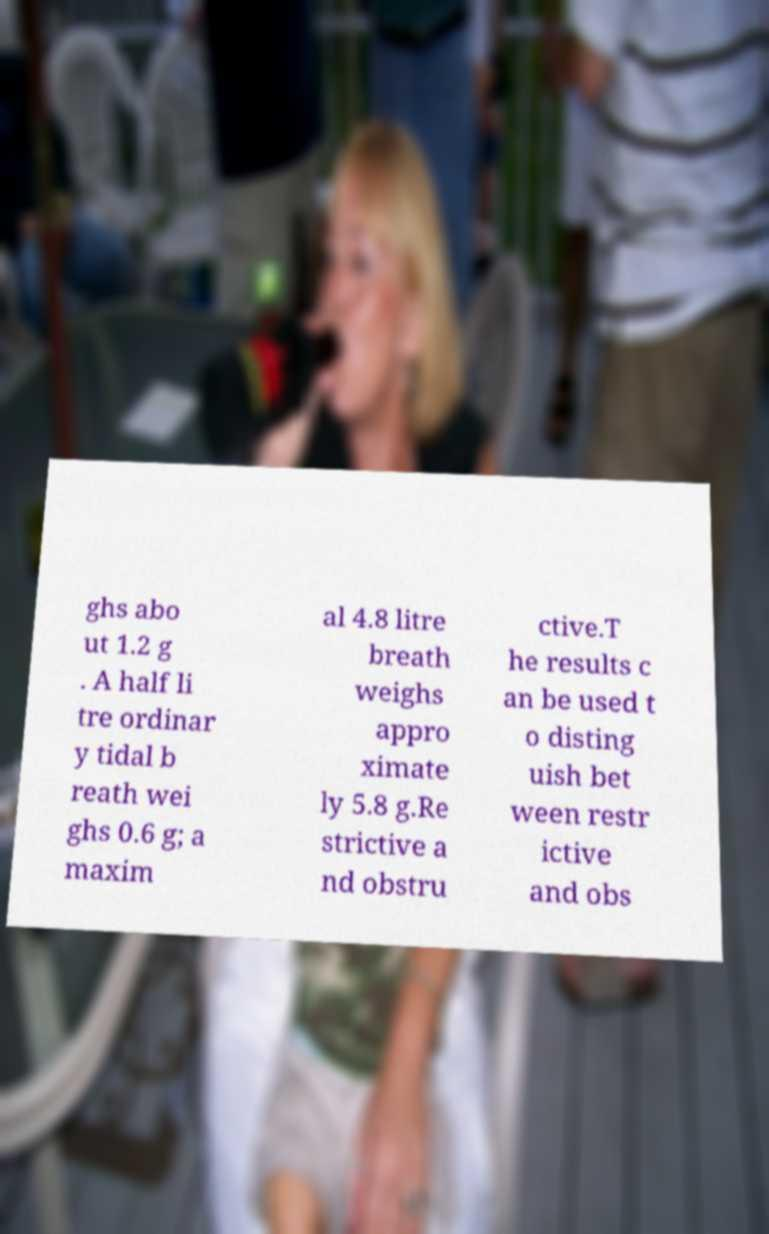Could you extract and type out the text from this image? ghs abo ut 1.2 g . A half li tre ordinar y tidal b reath wei ghs 0.6 g; a maxim al 4.8 litre breath weighs appro ximate ly 5.8 g.Re strictive a nd obstru ctive.T he results c an be used t o disting uish bet ween restr ictive and obs 